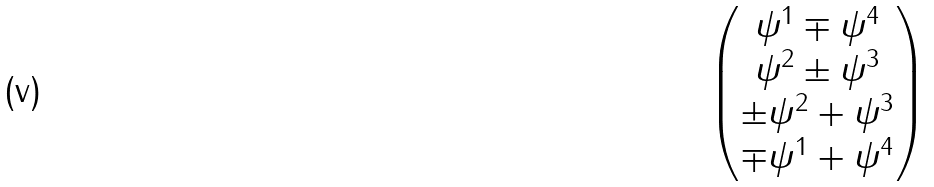<formula> <loc_0><loc_0><loc_500><loc_500>\begin{pmatrix} \psi ^ { 1 } \mp \psi ^ { 4 } \\ \psi ^ { 2 } \pm \psi ^ { 3 } \\ \pm \psi ^ { 2 } + \psi ^ { 3 } \\ \mp \psi ^ { 1 } + \psi ^ { 4 } \end{pmatrix}</formula> 